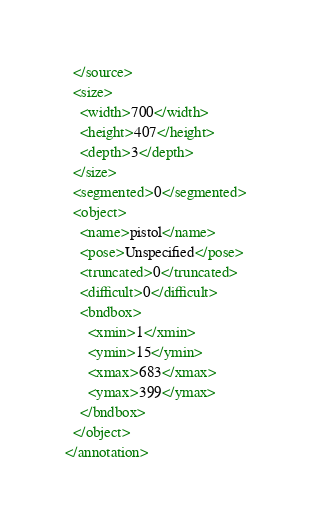Convert code to text. <code><loc_0><loc_0><loc_500><loc_500><_XML_>  </source>
  <size>
    <width>700</width>
    <height>407</height>
    <depth>3</depth>
  </size>
  <segmented>0</segmented>
  <object>
    <name>pistol</name>
    <pose>Unspecified</pose>
    <truncated>0</truncated>
    <difficult>0</difficult>
    <bndbox>
      <xmin>1</xmin>
      <ymin>15</ymin>
      <xmax>683</xmax>
      <ymax>399</ymax>
    </bndbox>
  </object>
</annotation>
</code> 